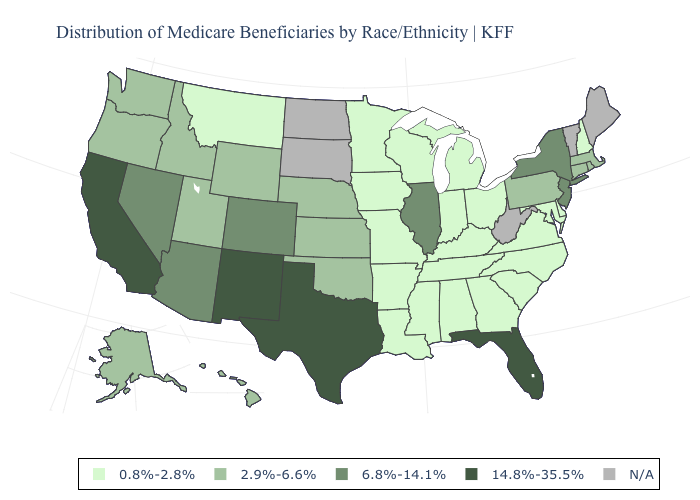What is the value of New York?
Give a very brief answer. 6.8%-14.1%. Does the first symbol in the legend represent the smallest category?
Answer briefly. Yes. Among the states that border Nebraska , which have the highest value?
Be succinct. Colorado. Which states hav the highest value in the South?
Quick response, please. Florida, Texas. What is the highest value in states that border Arkansas?
Answer briefly. 14.8%-35.5%. How many symbols are there in the legend?
Write a very short answer. 5. Name the states that have a value in the range 0.8%-2.8%?
Quick response, please. Alabama, Arkansas, Delaware, Georgia, Indiana, Iowa, Kentucky, Louisiana, Maryland, Michigan, Minnesota, Mississippi, Missouri, Montana, New Hampshire, North Carolina, Ohio, South Carolina, Tennessee, Virginia, Wisconsin. Does California have the lowest value in the USA?
Write a very short answer. No. What is the highest value in the USA?
Keep it brief. 14.8%-35.5%. Does New Mexico have the highest value in the West?
Be succinct. Yes. How many symbols are there in the legend?
Quick response, please. 5. What is the highest value in the USA?
Concise answer only. 14.8%-35.5%. What is the value of Arizona?
Write a very short answer. 6.8%-14.1%. What is the highest value in states that border Texas?
Quick response, please. 14.8%-35.5%. 